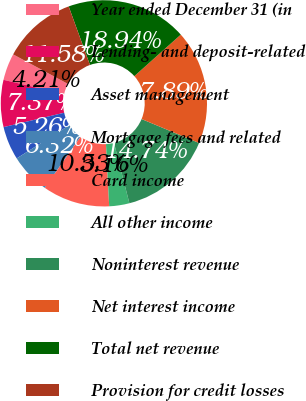Convert chart. <chart><loc_0><loc_0><loc_500><loc_500><pie_chart><fcel>Year ended December 31 (in<fcel>Lending- and deposit-related<fcel>Asset management<fcel>Mortgage fees and related<fcel>Card income<fcel>All other income<fcel>Noninterest revenue<fcel>Net interest income<fcel>Total net revenue<fcel>Provision for credit losses<nl><fcel>4.21%<fcel>7.37%<fcel>5.26%<fcel>6.32%<fcel>10.53%<fcel>3.16%<fcel>14.74%<fcel>17.89%<fcel>18.94%<fcel>11.58%<nl></chart> 